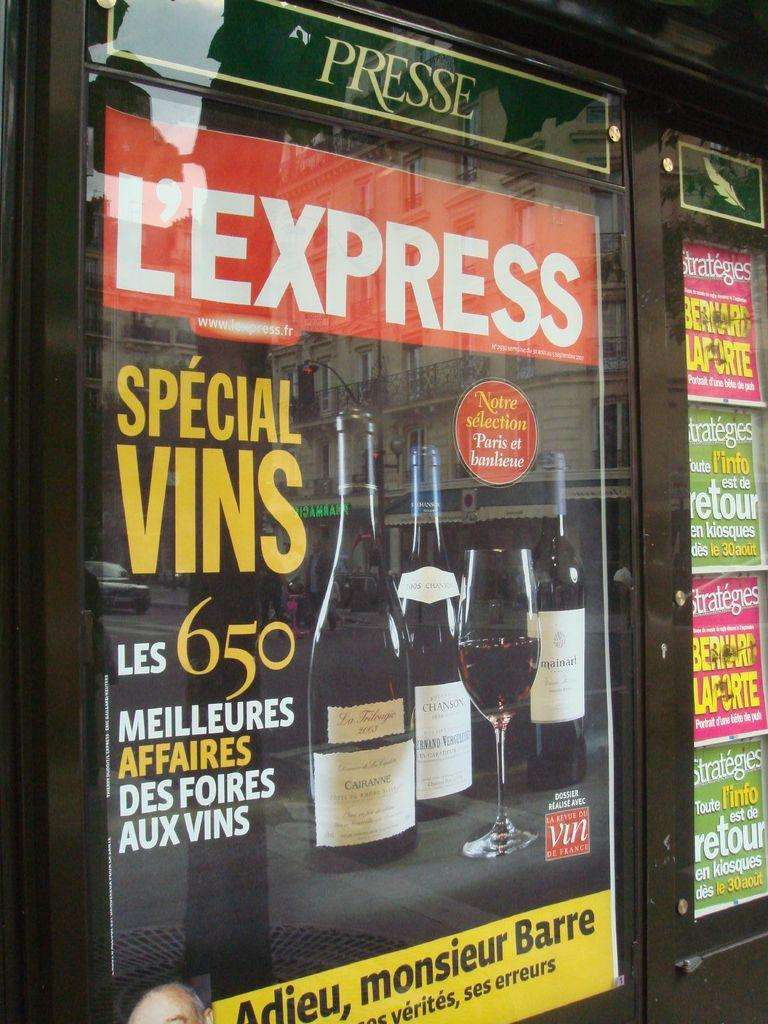What type of door is visible in the image? There is a glass door in the image. What is the color of the glass door? The glass door is black in color. What is attached to the glass door? There are posters on the glass door. What can be seen on the posters? The posters have text written on them. What beverage-related items are present in the image? There is a wine bottle and a wine glass in the image. Can you tell me how many experts are depicted on the bridge in the image? There is no bridge or experts present in the image. What type of fly is buzzing around the wine glass in the image? There are no flies present in the image. 